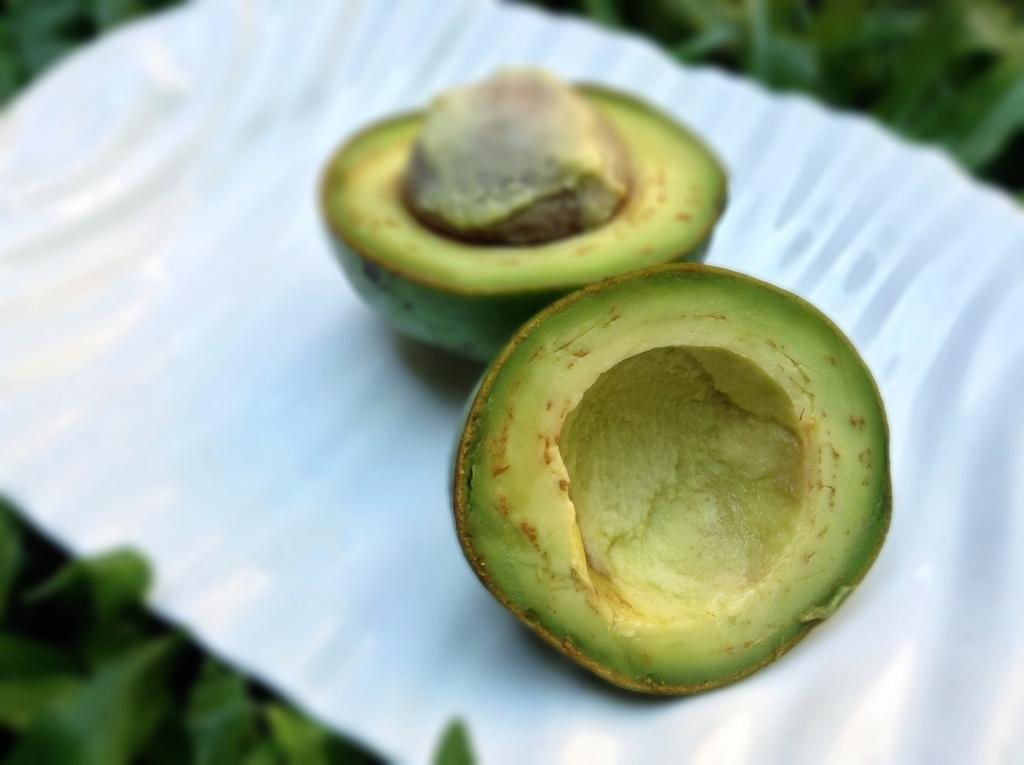What type of food item is present in the image? There is a fruit in the image. Where is the fruit placed in the image? The fruit is on an object that resembles a plate. What can be seen in the background of the image? There is a plant in the background of the image. How many geese are visible in the image? There are no geese present in the image. What is the zinc content of the fruit in the image? The zinc content of the fruit cannot be determined from the image alone. 